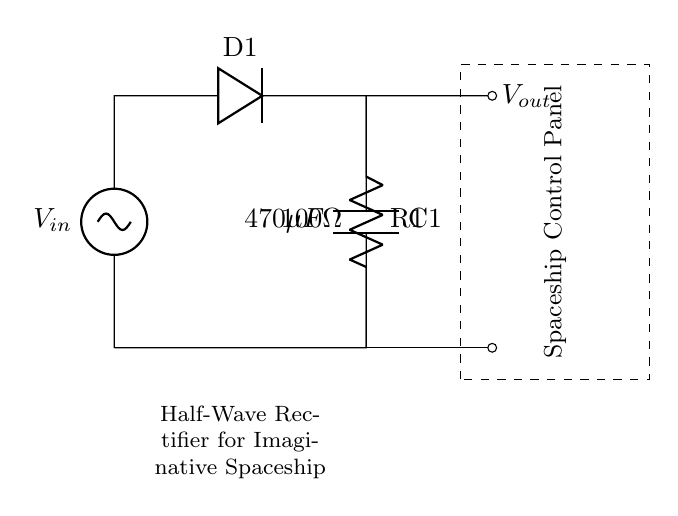What is the type of rectifier in this circuit? The circuit is identified as a half-wave rectifier due to the presence of a single diode which allows current to flow in only one direction, effectively converting AC to DC.
Answer: Half-wave rectifier What is the value of the resistor in this circuit? The diagram shows a resistor labeled R1 with a value of 100 ohms, indicating the resistance it offers in the circuit.
Answer: 100 ohms What component is used to smooth the output voltage? The circuit includes a capacitor labeled C1, which has a value of 470 microfarads. Capacitors are commonly used in rectifier circuits to smooth out fluctuations in the output voltage.
Answer: 470 microfarads What is the purpose of the diode D1 in this circuit? Diode D1 allows current to flow during the positive half of the AC cycle while blocking the negative half, thus facilitating the rectification process essential in converting AC to DC for the spaceship control panel.
Answer: Rectification What is the output voltage connection labeled as? The output voltage connection is labeled as Vout, indicating where the DC voltage can be measured to power the spaceship control panel.
Answer: Vout 